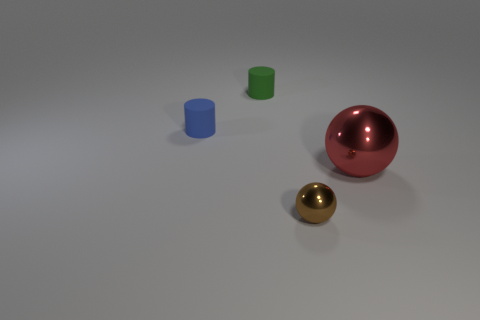Add 3 green matte objects. How many objects exist? 7 Subtract 0 red blocks. How many objects are left? 4 Subtract all cyan cylinders. Subtract all green cubes. How many cylinders are left? 2 Subtract all small balls. Subtract all small green cylinders. How many objects are left? 2 Add 4 red objects. How many red objects are left? 5 Add 4 tiny green cylinders. How many tiny green cylinders exist? 5 